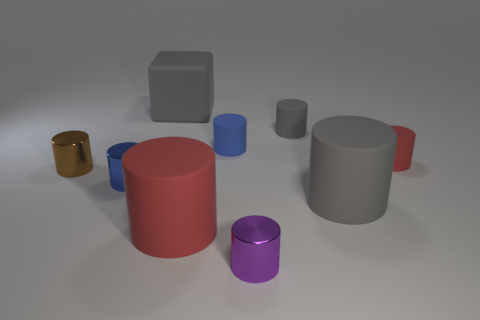Subtract all gray cylinders. How many cylinders are left? 6 Subtract all tiny red matte cylinders. How many cylinders are left? 7 Subtract 3 cylinders. How many cylinders are left? 5 Subtract all brown cylinders. Subtract all gray spheres. How many cylinders are left? 7 Add 1 large cyan matte balls. How many objects exist? 10 Subtract all cylinders. How many objects are left? 1 Add 9 gray rubber blocks. How many gray rubber blocks exist? 10 Subtract 1 red cylinders. How many objects are left? 8 Subtract all small gray matte things. Subtract all large gray matte cylinders. How many objects are left? 7 Add 7 large red rubber objects. How many large red rubber objects are left? 8 